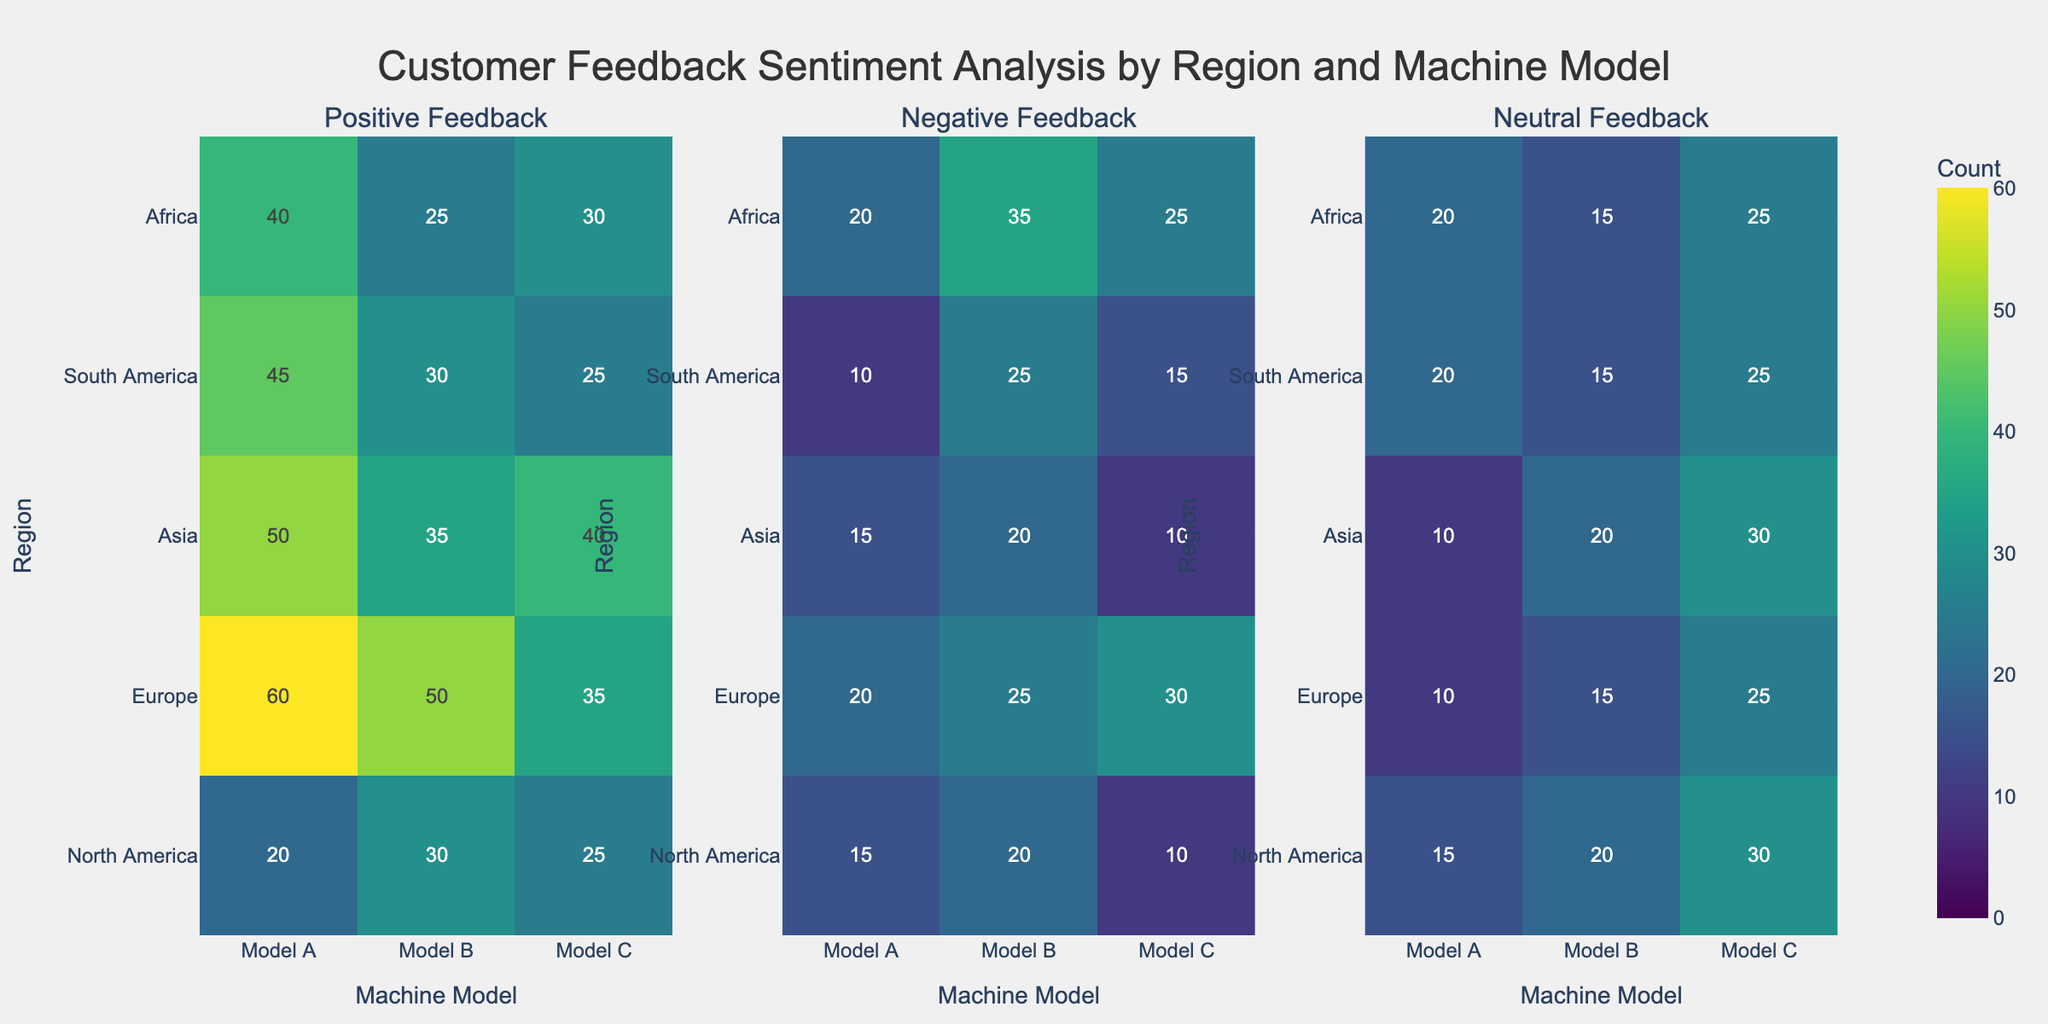What is the title of the heatmap? The title is usually displayed at the top center of the figure and provides an overview of the visualized data.
Answer: Customer Feedback Sentiment Analysis by Region and Machine Model Which machine model has the highest positive feedback in Asia? Locate the Positive Feedback subplot, find the column for Machine Model in Asia, and compare the values for all models.
Answer: Model A Which region has the lowest neutral feedback for Model C? Look at the Neutral Feedback subplot, find the row corresponding to Model C, and compare the values across all regions.
Answer: Europe What is the sum of positive feedback for Model B across all regions? Locate the Positive Feedback subplot, find the column for Model B, and add up the counts for each region (30+35+50+25+30).
Answer: 170 Which region has the highest negative feedback for any machine model? Look at the Negative Feedback subplot, find the region with the highest value in any model’s column.
Answer: South America (Model B) How does the positive feedback for Model A in North America compare to Europe? Compare the values of the two regions for Model A in the Positive Feedback subplot. North America has 45 and Europe has 50, so Europe has 5 more than North America.
Answer: Europe has more Which machine model has the most consistent feedback across all regions, considering only positive feedback? Identify the model with the least variance in its positive feedback values across all regions. Model B has values (30, 35, 50, 25, 30), showing relatively consistent feedback.
Answer: Model B What is the average negative feedback received by Model C across all regions? Sum the negative feedback values for Model C (15+10+30+25+10) and divide by the number of regions (5). (15+10+30+25+10) / 5 = 18
Answer: 18 Does South America have higher negative feedback for any model compared to the other regions? Check each machine model's column in the Negative Feedback subplot for South America and compare values with other regions. South America has higher feedback for Model B.
Answer: Yes, for Model B Which machine model has the least variation in neutral feedback across all regions? Assess the spread of neutral feedback values across regions to determine the least variance. Model A has values (20, 10, 10, 20, 15) which indicates lower variation compared to others.
Answer: Model A 